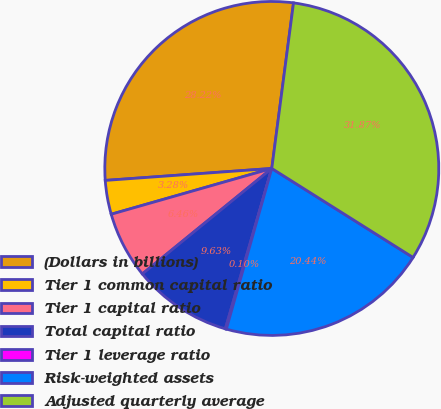<chart> <loc_0><loc_0><loc_500><loc_500><pie_chart><fcel>(Dollars in billions)<fcel>Tier 1 common capital ratio<fcel>Tier 1 capital ratio<fcel>Total capital ratio<fcel>Tier 1 leverage ratio<fcel>Risk-weighted assets<fcel>Adjusted quarterly average<nl><fcel>28.22%<fcel>3.28%<fcel>6.46%<fcel>9.63%<fcel>0.1%<fcel>20.44%<fcel>31.87%<nl></chart> 